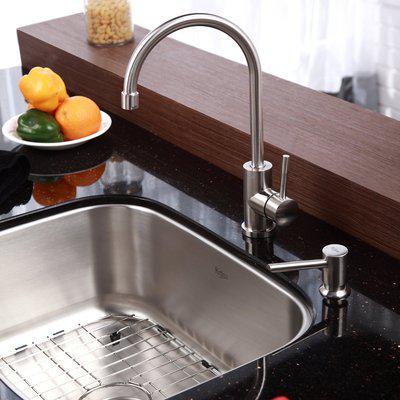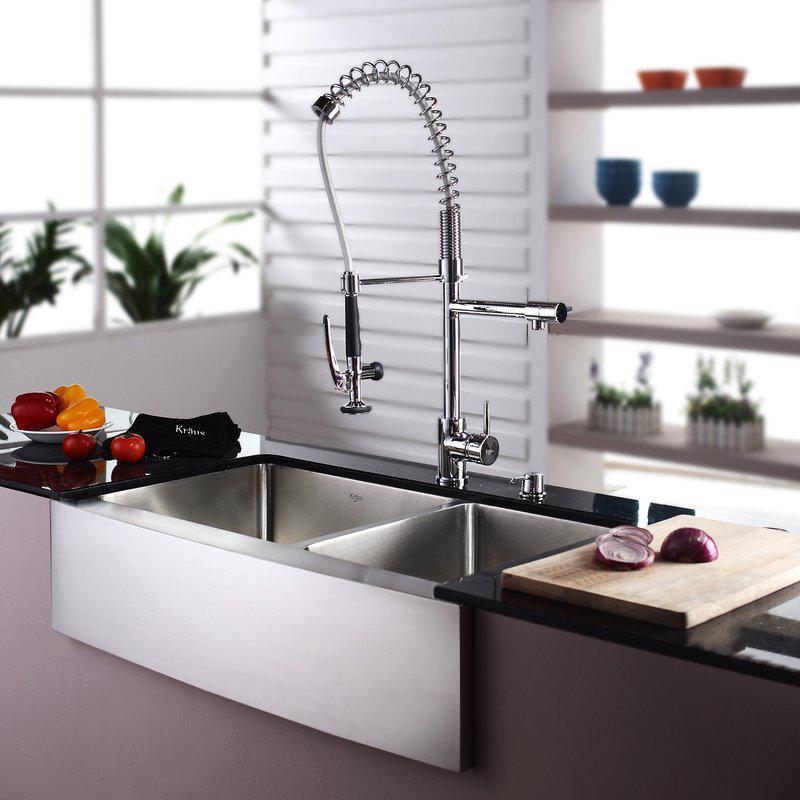The first image is the image on the left, the second image is the image on the right. Given the left and right images, does the statement "The right image shows a single-basin rectangular sink with a wire rack inside it." hold true? Answer yes or no. No. 